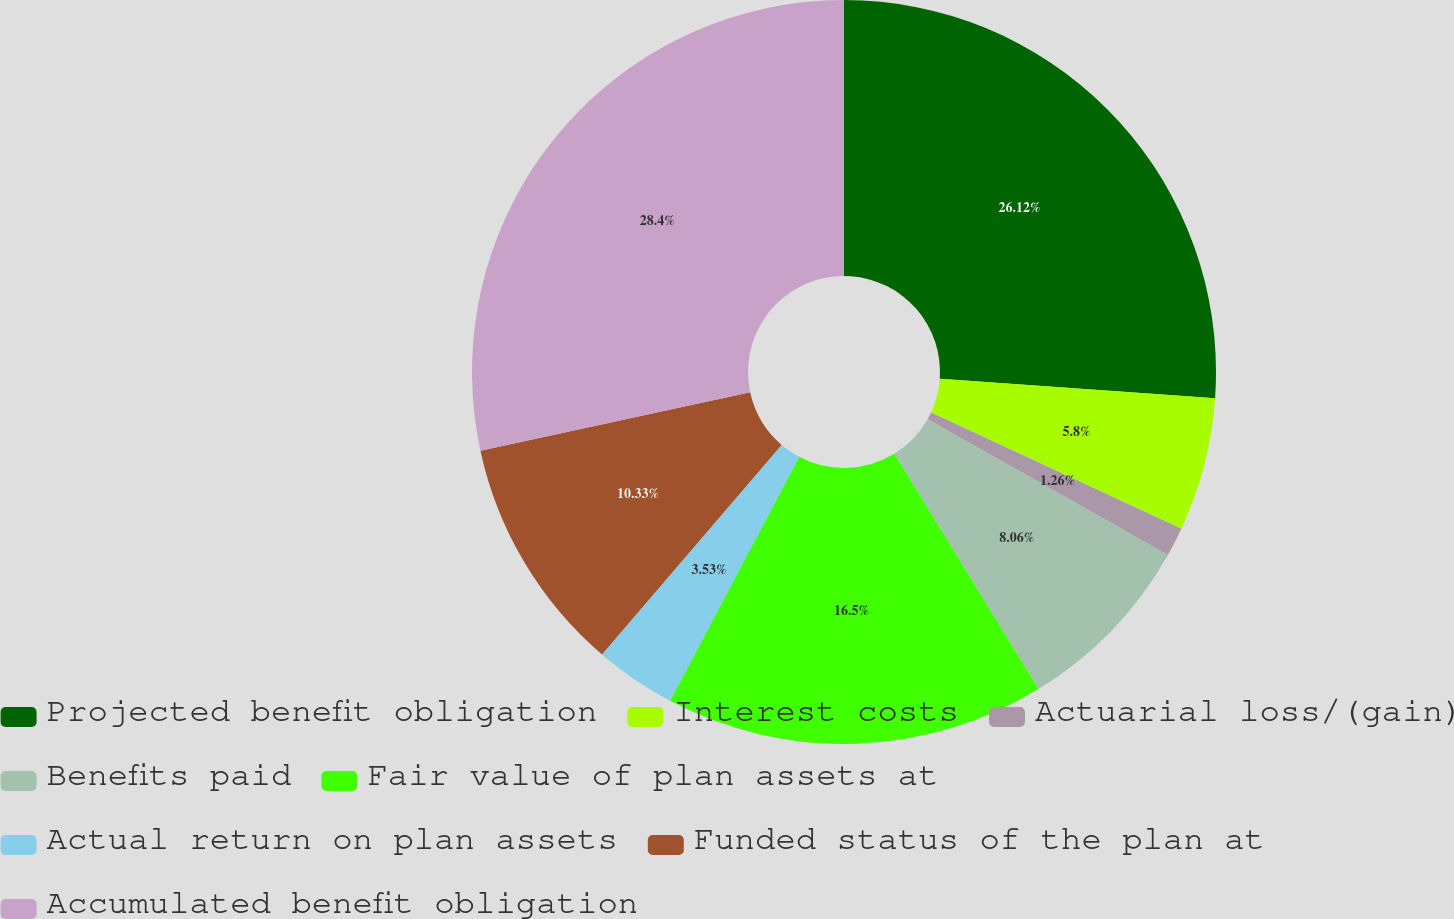Convert chart to OTSL. <chart><loc_0><loc_0><loc_500><loc_500><pie_chart><fcel>Projected benefit obligation<fcel>Interest costs<fcel>Actuarial loss/(gain)<fcel>Benefits paid<fcel>Fair value of plan assets at<fcel>Actual return on plan assets<fcel>Funded status of the plan at<fcel>Accumulated benefit obligation<nl><fcel>26.12%<fcel>5.8%<fcel>1.26%<fcel>8.06%<fcel>16.5%<fcel>3.53%<fcel>10.33%<fcel>28.39%<nl></chart> 